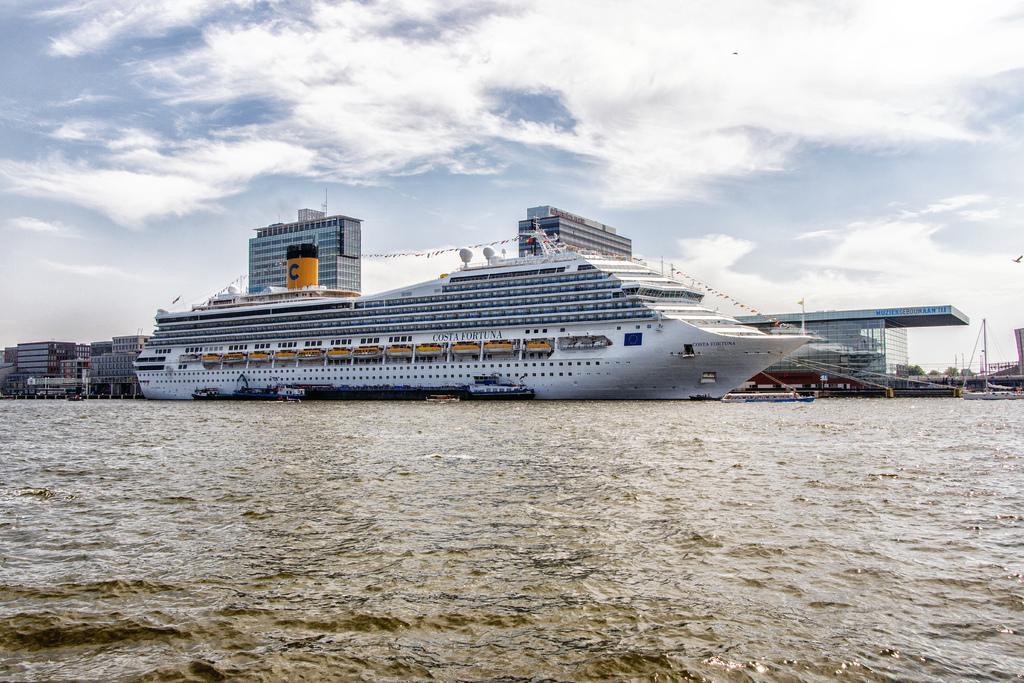How would you summarize this image in a sentence or two? In this picture we can see a ship and few boats on the water, in the background we can find few buildings and clouds. 